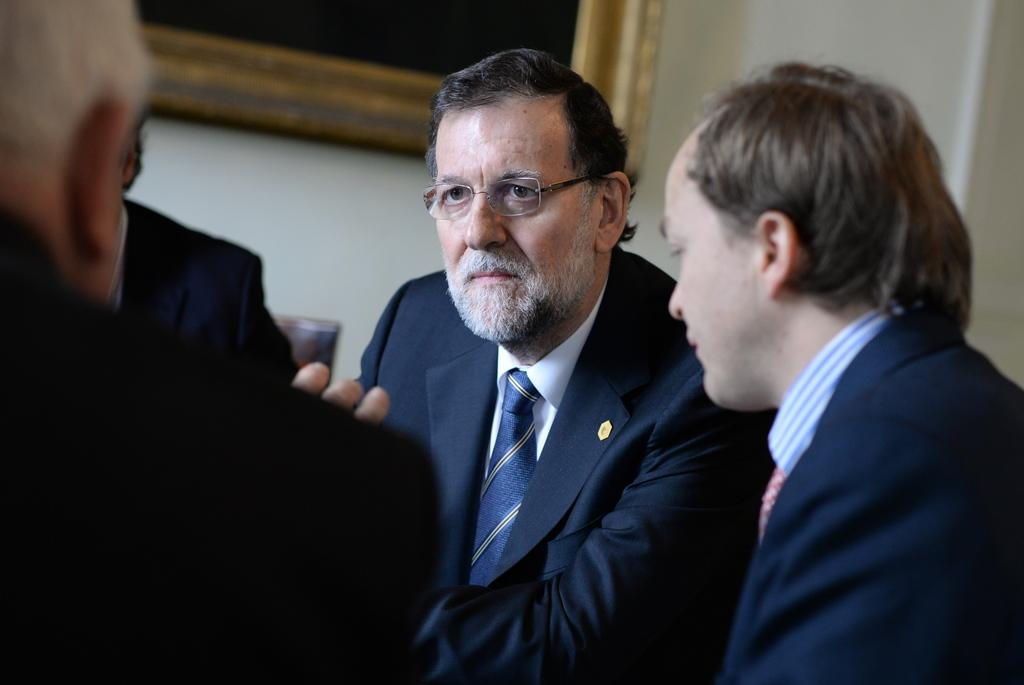How many people are sitting on the right side of the image? There are two persons in suits sitting on the right side of the image. How many people are sitting on the left side of the image? There are two persons sitting on the left side of the image. What can be seen on the white wall in the background of the image? There is a photo frame on a white wall in the background of the image. What type of shelf is visible in the image? There is no shelf visible in the image. What achievement is being celebrated by the persons in the image? The image does not provide any information about achievements or celebrations. 